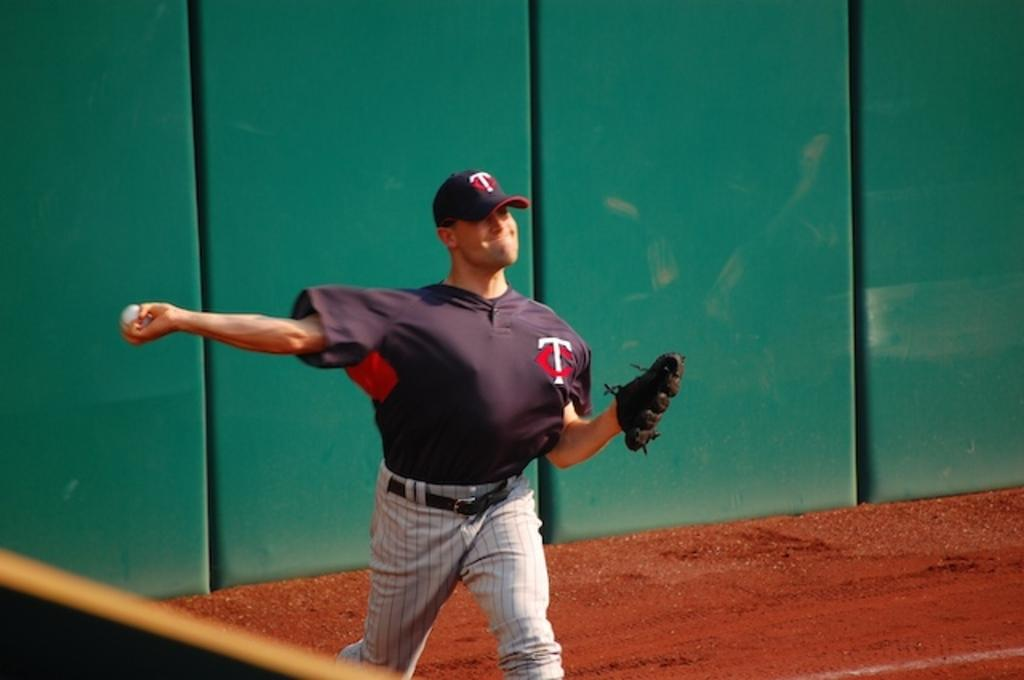<image>
Write a terse but informative summary of the picture. The baseball player in the outfield has a TC hat and shirt on. 